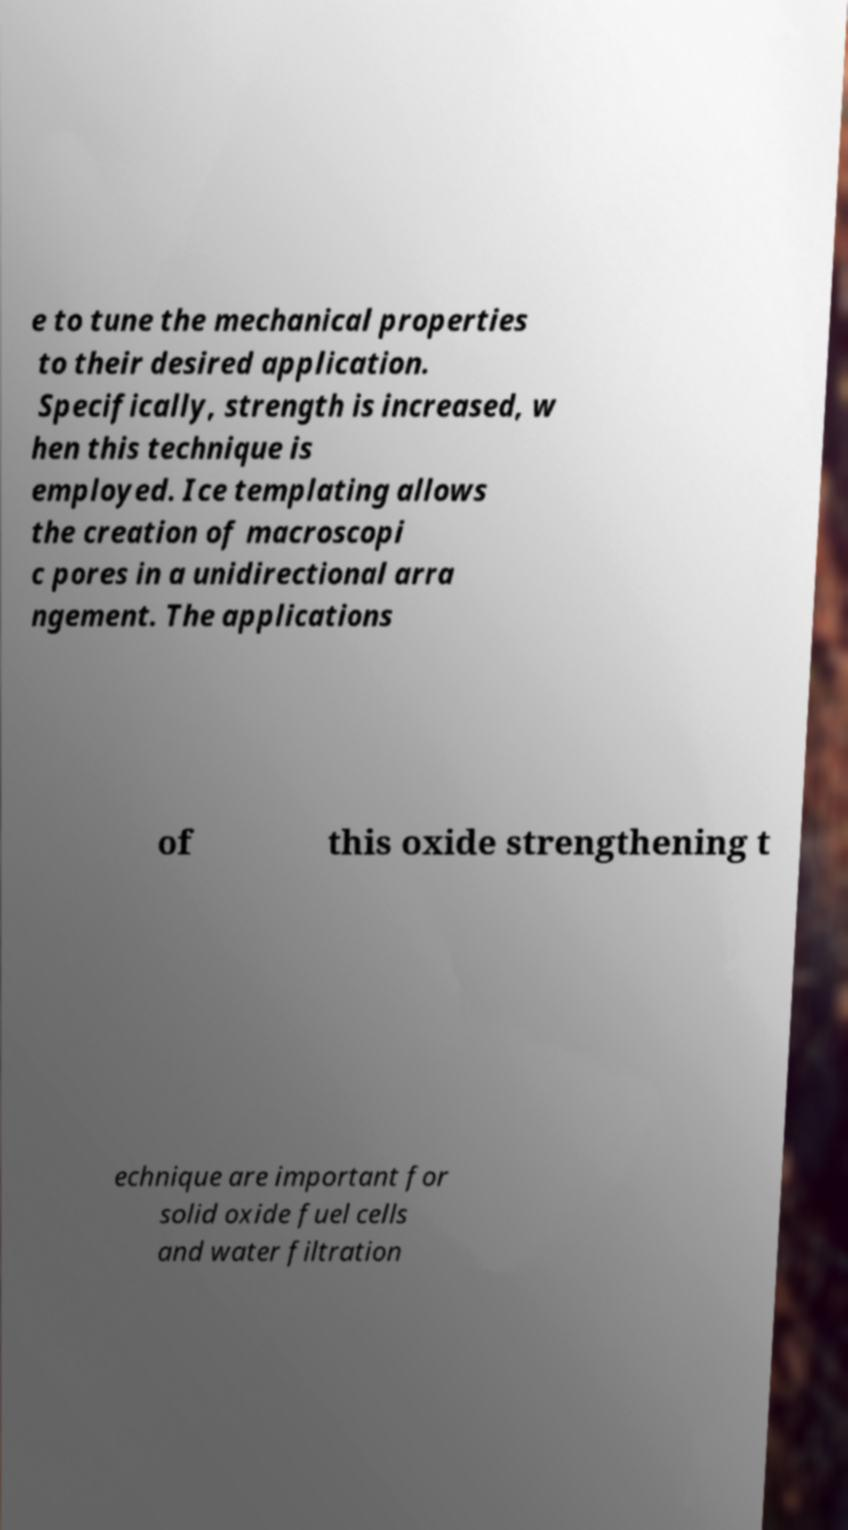What messages or text are displayed in this image? I need them in a readable, typed format. e to tune the mechanical properties to their desired application. Specifically, strength is increased, w hen this technique is employed. Ice templating allows the creation of macroscopi c pores in a unidirectional arra ngement. The applications of this oxide strengthening t echnique are important for solid oxide fuel cells and water filtration 